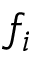Convert formula to latex. <formula><loc_0><loc_0><loc_500><loc_500>f _ { i }</formula> 